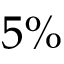<formula> <loc_0><loc_0><loc_500><loc_500>5 \%</formula> 